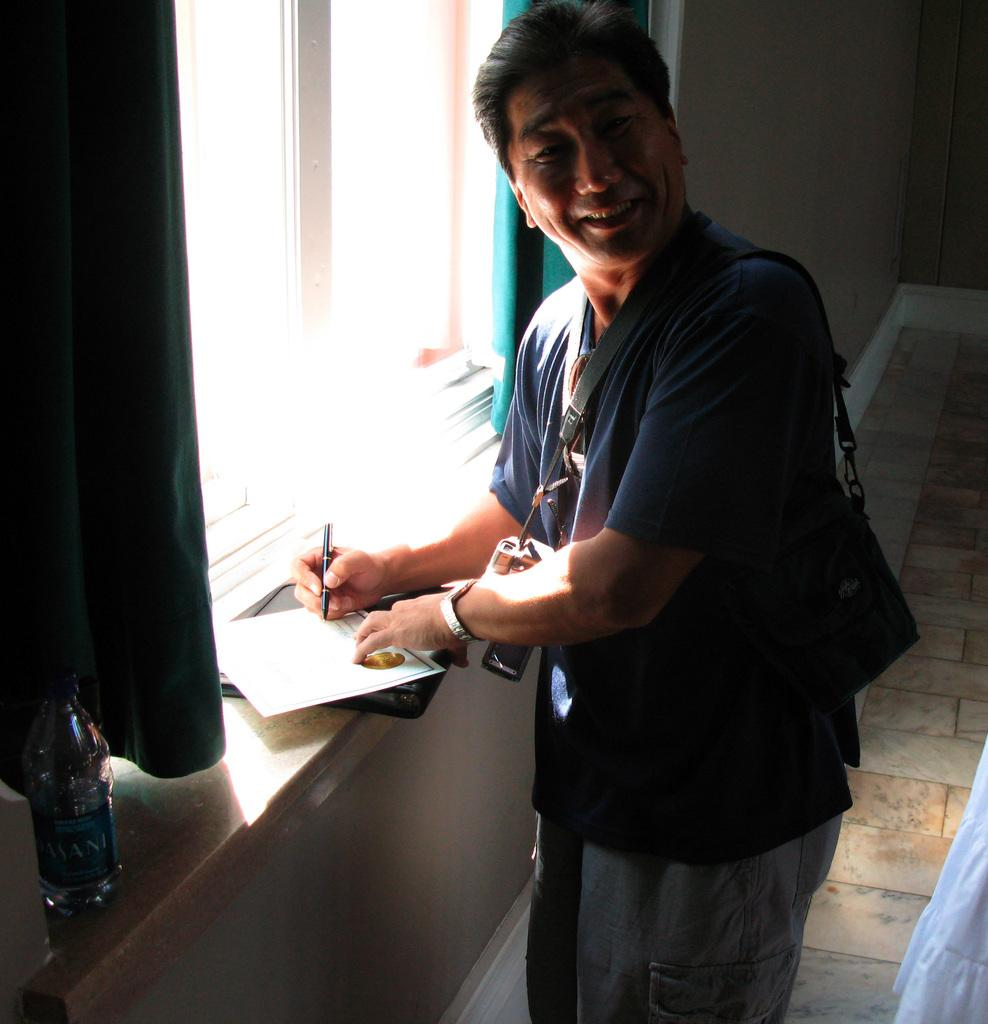Who is the main subject in the image? There is a man in the image. What is the man doing in the image? The man is standing and writing on paper. What tool is the man using to write? The man is using a pen to write. What type of bridge can be seen in the background of the image? There is no bridge present in the image; it only features a man standing and writing on paper. 